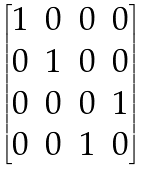<formula> <loc_0><loc_0><loc_500><loc_500>\begin{bmatrix} 1 & 0 & 0 & 0 \\ 0 & 1 & 0 & 0 \\ 0 & 0 & 0 & 1 \\ 0 & 0 & 1 & 0 \end{bmatrix}</formula> 